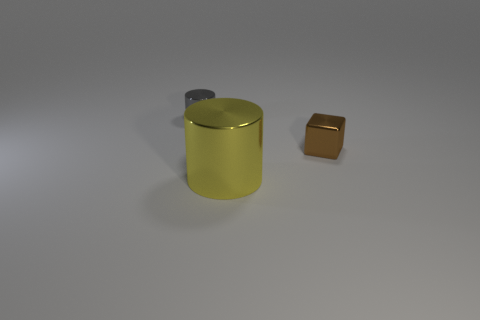What material is the cylinder in front of the small brown block?
Give a very brief answer. Metal. There is a yellow shiny object that is the same shape as the gray object; what size is it?
Your answer should be very brief. Large. Are there fewer small brown metal blocks in front of the tiny metallic block than tiny blue shiny blocks?
Your answer should be very brief. No. Is there a small rubber cube?
Offer a terse response. No. There is another metal thing that is the same shape as the small gray object; what color is it?
Give a very brief answer. Yellow. There is a cylinder that is on the right side of the small gray cylinder; is it the same color as the tiny cube?
Make the answer very short. No. Is the size of the brown metal block the same as the gray metallic cylinder?
Provide a succinct answer. Yes. What shape is the small gray thing that is made of the same material as the brown cube?
Your response must be concise. Cylinder. How many other things are the same shape as the yellow thing?
Give a very brief answer. 1. There is a tiny object to the right of the tiny shiny object that is left of the tiny object on the right side of the yellow metal cylinder; what shape is it?
Offer a terse response. Cube. 